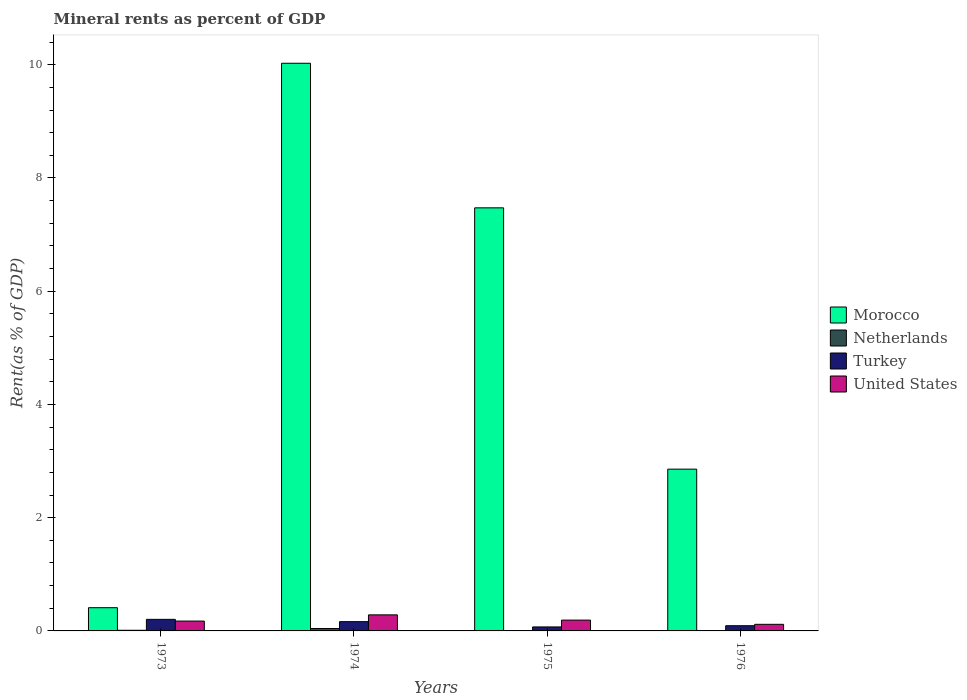How many different coloured bars are there?
Offer a very short reply. 4. How many groups of bars are there?
Keep it short and to the point. 4. Are the number of bars per tick equal to the number of legend labels?
Provide a succinct answer. Yes. Are the number of bars on each tick of the X-axis equal?
Your answer should be very brief. Yes. How many bars are there on the 4th tick from the right?
Your answer should be very brief. 4. What is the label of the 3rd group of bars from the left?
Keep it short and to the point. 1975. In how many cases, is the number of bars for a given year not equal to the number of legend labels?
Provide a succinct answer. 0. What is the mineral rent in Morocco in 1974?
Offer a very short reply. 10.03. Across all years, what is the maximum mineral rent in United States?
Provide a short and direct response. 0.28. Across all years, what is the minimum mineral rent in Netherlands?
Ensure brevity in your answer.  0. In which year was the mineral rent in Netherlands maximum?
Your answer should be very brief. 1974. In which year was the mineral rent in Turkey minimum?
Offer a terse response. 1975. What is the total mineral rent in Morocco in the graph?
Provide a succinct answer. 20.77. What is the difference between the mineral rent in United States in 1973 and that in 1976?
Your answer should be compact. 0.06. What is the difference between the mineral rent in Turkey in 1976 and the mineral rent in Morocco in 1974?
Your response must be concise. -9.93. What is the average mineral rent in Netherlands per year?
Your answer should be compact. 0.01. In the year 1976, what is the difference between the mineral rent in United States and mineral rent in Netherlands?
Keep it short and to the point. 0.12. What is the ratio of the mineral rent in Netherlands in 1974 to that in 1975?
Keep it short and to the point. 22.01. Is the difference between the mineral rent in United States in 1973 and 1974 greater than the difference between the mineral rent in Netherlands in 1973 and 1974?
Your answer should be very brief. No. What is the difference between the highest and the second highest mineral rent in Turkey?
Provide a succinct answer. 0.04. What is the difference between the highest and the lowest mineral rent in Netherlands?
Make the answer very short. 0.04. Is it the case that in every year, the sum of the mineral rent in United States and mineral rent in Turkey is greater than the sum of mineral rent in Morocco and mineral rent in Netherlands?
Provide a succinct answer. Yes. What does the 1st bar from the left in 1974 represents?
Offer a very short reply. Morocco. What does the 4th bar from the right in 1974 represents?
Your answer should be compact. Morocco. Is it the case that in every year, the sum of the mineral rent in Morocco and mineral rent in Netherlands is greater than the mineral rent in Turkey?
Your response must be concise. Yes. Are all the bars in the graph horizontal?
Your response must be concise. No. What is the difference between two consecutive major ticks on the Y-axis?
Give a very brief answer. 2. Does the graph contain grids?
Provide a succinct answer. No. What is the title of the graph?
Your response must be concise. Mineral rents as percent of GDP. Does "Greece" appear as one of the legend labels in the graph?
Provide a short and direct response. No. What is the label or title of the Y-axis?
Provide a short and direct response. Rent(as % of GDP). What is the Rent(as % of GDP) in Morocco in 1973?
Keep it short and to the point. 0.41. What is the Rent(as % of GDP) of Netherlands in 1973?
Ensure brevity in your answer.  0.01. What is the Rent(as % of GDP) in Turkey in 1973?
Provide a short and direct response. 0.2. What is the Rent(as % of GDP) in United States in 1973?
Ensure brevity in your answer.  0.17. What is the Rent(as % of GDP) of Morocco in 1974?
Ensure brevity in your answer.  10.03. What is the Rent(as % of GDP) in Netherlands in 1974?
Your response must be concise. 0.04. What is the Rent(as % of GDP) of Turkey in 1974?
Provide a short and direct response. 0.16. What is the Rent(as % of GDP) of United States in 1974?
Ensure brevity in your answer.  0.28. What is the Rent(as % of GDP) in Morocco in 1975?
Provide a short and direct response. 7.47. What is the Rent(as % of GDP) in Netherlands in 1975?
Provide a short and direct response. 0. What is the Rent(as % of GDP) of Turkey in 1975?
Keep it short and to the point. 0.07. What is the Rent(as % of GDP) in United States in 1975?
Provide a succinct answer. 0.19. What is the Rent(as % of GDP) of Morocco in 1976?
Keep it short and to the point. 2.86. What is the Rent(as % of GDP) of Netherlands in 1976?
Your response must be concise. 0. What is the Rent(as % of GDP) of Turkey in 1976?
Your response must be concise. 0.09. What is the Rent(as % of GDP) in United States in 1976?
Ensure brevity in your answer.  0.12. Across all years, what is the maximum Rent(as % of GDP) of Morocco?
Offer a terse response. 10.03. Across all years, what is the maximum Rent(as % of GDP) of Netherlands?
Provide a short and direct response. 0.04. Across all years, what is the maximum Rent(as % of GDP) in Turkey?
Offer a very short reply. 0.2. Across all years, what is the maximum Rent(as % of GDP) in United States?
Offer a very short reply. 0.28. Across all years, what is the minimum Rent(as % of GDP) in Morocco?
Your answer should be very brief. 0.41. Across all years, what is the minimum Rent(as % of GDP) of Netherlands?
Provide a succinct answer. 0. Across all years, what is the minimum Rent(as % of GDP) in Turkey?
Offer a terse response. 0.07. Across all years, what is the minimum Rent(as % of GDP) in United States?
Offer a very short reply. 0.12. What is the total Rent(as % of GDP) in Morocco in the graph?
Offer a very short reply. 20.77. What is the total Rent(as % of GDP) in Netherlands in the graph?
Offer a very short reply. 0.06. What is the total Rent(as % of GDP) in Turkey in the graph?
Your answer should be very brief. 0.53. What is the total Rent(as % of GDP) in United States in the graph?
Offer a very short reply. 0.77. What is the difference between the Rent(as % of GDP) in Morocco in 1973 and that in 1974?
Provide a succinct answer. -9.62. What is the difference between the Rent(as % of GDP) of Netherlands in 1973 and that in 1974?
Keep it short and to the point. -0.03. What is the difference between the Rent(as % of GDP) in Turkey in 1973 and that in 1974?
Offer a very short reply. 0.04. What is the difference between the Rent(as % of GDP) in United States in 1973 and that in 1974?
Your answer should be compact. -0.11. What is the difference between the Rent(as % of GDP) in Morocco in 1973 and that in 1975?
Your response must be concise. -7.06. What is the difference between the Rent(as % of GDP) of Netherlands in 1973 and that in 1975?
Offer a very short reply. 0.01. What is the difference between the Rent(as % of GDP) in Turkey in 1973 and that in 1975?
Ensure brevity in your answer.  0.13. What is the difference between the Rent(as % of GDP) in United States in 1973 and that in 1975?
Provide a short and direct response. -0.02. What is the difference between the Rent(as % of GDP) in Morocco in 1973 and that in 1976?
Provide a short and direct response. -2.45. What is the difference between the Rent(as % of GDP) in Netherlands in 1973 and that in 1976?
Provide a short and direct response. 0.01. What is the difference between the Rent(as % of GDP) in Turkey in 1973 and that in 1976?
Offer a very short reply. 0.11. What is the difference between the Rent(as % of GDP) of United States in 1973 and that in 1976?
Provide a succinct answer. 0.06. What is the difference between the Rent(as % of GDP) of Morocco in 1974 and that in 1975?
Ensure brevity in your answer.  2.55. What is the difference between the Rent(as % of GDP) of Netherlands in 1974 and that in 1975?
Your answer should be very brief. 0.04. What is the difference between the Rent(as % of GDP) of Turkey in 1974 and that in 1975?
Offer a terse response. 0.09. What is the difference between the Rent(as % of GDP) in United States in 1974 and that in 1975?
Ensure brevity in your answer.  0.09. What is the difference between the Rent(as % of GDP) of Morocco in 1974 and that in 1976?
Provide a succinct answer. 7.17. What is the difference between the Rent(as % of GDP) of Netherlands in 1974 and that in 1976?
Ensure brevity in your answer.  0.04. What is the difference between the Rent(as % of GDP) of Turkey in 1974 and that in 1976?
Offer a very short reply. 0.07. What is the difference between the Rent(as % of GDP) of United States in 1974 and that in 1976?
Offer a terse response. 0.17. What is the difference between the Rent(as % of GDP) of Morocco in 1975 and that in 1976?
Your answer should be compact. 4.62. What is the difference between the Rent(as % of GDP) in Netherlands in 1975 and that in 1976?
Provide a short and direct response. 0. What is the difference between the Rent(as % of GDP) of Turkey in 1975 and that in 1976?
Ensure brevity in your answer.  -0.02. What is the difference between the Rent(as % of GDP) in United States in 1975 and that in 1976?
Ensure brevity in your answer.  0.07. What is the difference between the Rent(as % of GDP) in Morocco in 1973 and the Rent(as % of GDP) in Netherlands in 1974?
Your answer should be compact. 0.37. What is the difference between the Rent(as % of GDP) of Morocco in 1973 and the Rent(as % of GDP) of Turkey in 1974?
Keep it short and to the point. 0.25. What is the difference between the Rent(as % of GDP) of Morocco in 1973 and the Rent(as % of GDP) of United States in 1974?
Ensure brevity in your answer.  0.13. What is the difference between the Rent(as % of GDP) of Netherlands in 1973 and the Rent(as % of GDP) of Turkey in 1974?
Your answer should be very brief. -0.15. What is the difference between the Rent(as % of GDP) of Netherlands in 1973 and the Rent(as % of GDP) of United States in 1974?
Give a very brief answer. -0.27. What is the difference between the Rent(as % of GDP) in Turkey in 1973 and the Rent(as % of GDP) in United States in 1974?
Keep it short and to the point. -0.08. What is the difference between the Rent(as % of GDP) of Morocco in 1973 and the Rent(as % of GDP) of Netherlands in 1975?
Provide a succinct answer. 0.41. What is the difference between the Rent(as % of GDP) of Morocco in 1973 and the Rent(as % of GDP) of Turkey in 1975?
Ensure brevity in your answer.  0.34. What is the difference between the Rent(as % of GDP) in Morocco in 1973 and the Rent(as % of GDP) in United States in 1975?
Your response must be concise. 0.22. What is the difference between the Rent(as % of GDP) in Netherlands in 1973 and the Rent(as % of GDP) in Turkey in 1975?
Your answer should be very brief. -0.06. What is the difference between the Rent(as % of GDP) of Netherlands in 1973 and the Rent(as % of GDP) of United States in 1975?
Provide a succinct answer. -0.18. What is the difference between the Rent(as % of GDP) in Turkey in 1973 and the Rent(as % of GDP) in United States in 1975?
Give a very brief answer. 0.01. What is the difference between the Rent(as % of GDP) of Morocco in 1973 and the Rent(as % of GDP) of Netherlands in 1976?
Make the answer very short. 0.41. What is the difference between the Rent(as % of GDP) in Morocco in 1973 and the Rent(as % of GDP) in Turkey in 1976?
Offer a terse response. 0.32. What is the difference between the Rent(as % of GDP) in Morocco in 1973 and the Rent(as % of GDP) in United States in 1976?
Ensure brevity in your answer.  0.29. What is the difference between the Rent(as % of GDP) of Netherlands in 1973 and the Rent(as % of GDP) of Turkey in 1976?
Offer a terse response. -0.08. What is the difference between the Rent(as % of GDP) of Netherlands in 1973 and the Rent(as % of GDP) of United States in 1976?
Keep it short and to the point. -0.11. What is the difference between the Rent(as % of GDP) in Turkey in 1973 and the Rent(as % of GDP) in United States in 1976?
Provide a succinct answer. 0.09. What is the difference between the Rent(as % of GDP) of Morocco in 1974 and the Rent(as % of GDP) of Netherlands in 1975?
Your answer should be very brief. 10.02. What is the difference between the Rent(as % of GDP) of Morocco in 1974 and the Rent(as % of GDP) of Turkey in 1975?
Give a very brief answer. 9.96. What is the difference between the Rent(as % of GDP) in Morocco in 1974 and the Rent(as % of GDP) in United States in 1975?
Keep it short and to the point. 9.83. What is the difference between the Rent(as % of GDP) in Netherlands in 1974 and the Rent(as % of GDP) in Turkey in 1975?
Your answer should be very brief. -0.03. What is the difference between the Rent(as % of GDP) of Netherlands in 1974 and the Rent(as % of GDP) of United States in 1975?
Your answer should be compact. -0.15. What is the difference between the Rent(as % of GDP) in Turkey in 1974 and the Rent(as % of GDP) in United States in 1975?
Make the answer very short. -0.03. What is the difference between the Rent(as % of GDP) in Morocco in 1974 and the Rent(as % of GDP) in Netherlands in 1976?
Your answer should be compact. 10.03. What is the difference between the Rent(as % of GDP) in Morocco in 1974 and the Rent(as % of GDP) in Turkey in 1976?
Ensure brevity in your answer.  9.93. What is the difference between the Rent(as % of GDP) of Morocco in 1974 and the Rent(as % of GDP) of United States in 1976?
Ensure brevity in your answer.  9.91. What is the difference between the Rent(as % of GDP) of Netherlands in 1974 and the Rent(as % of GDP) of Turkey in 1976?
Make the answer very short. -0.05. What is the difference between the Rent(as % of GDP) in Netherlands in 1974 and the Rent(as % of GDP) in United States in 1976?
Offer a very short reply. -0.07. What is the difference between the Rent(as % of GDP) of Turkey in 1974 and the Rent(as % of GDP) of United States in 1976?
Offer a terse response. 0.05. What is the difference between the Rent(as % of GDP) in Morocco in 1975 and the Rent(as % of GDP) in Netherlands in 1976?
Your answer should be very brief. 7.47. What is the difference between the Rent(as % of GDP) of Morocco in 1975 and the Rent(as % of GDP) of Turkey in 1976?
Offer a very short reply. 7.38. What is the difference between the Rent(as % of GDP) in Morocco in 1975 and the Rent(as % of GDP) in United States in 1976?
Your answer should be compact. 7.36. What is the difference between the Rent(as % of GDP) of Netherlands in 1975 and the Rent(as % of GDP) of Turkey in 1976?
Your response must be concise. -0.09. What is the difference between the Rent(as % of GDP) in Netherlands in 1975 and the Rent(as % of GDP) in United States in 1976?
Give a very brief answer. -0.11. What is the difference between the Rent(as % of GDP) of Turkey in 1975 and the Rent(as % of GDP) of United States in 1976?
Your answer should be very brief. -0.05. What is the average Rent(as % of GDP) in Morocco per year?
Provide a short and direct response. 5.19. What is the average Rent(as % of GDP) in Netherlands per year?
Ensure brevity in your answer.  0.01. What is the average Rent(as % of GDP) of Turkey per year?
Your answer should be very brief. 0.13. What is the average Rent(as % of GDP) of United States per year?
Ensure brevity in your answer.  0.19. In the year 1973, what is the difference between the Rent(as % of GDP) of Morocco and Rent(as % of GDP) of Netherlands?
Your answer should be compact. 0.4. In the year 1973, what is the difference between the Rent(as % of GDP) of Morocco and Rent(as % of GDP) of Turkey?
Give a very brief answer. 0.21. In the year 1973, what is the difference between the Rent(as % of GDP) in Morocco and Rent(as % of GDP) in United States?
Give a very brief answer. 0.24. In the year 1973, what is the difference between the Rent(as % of GDP) of Netherlands and Rent(as % of GDP) of Turkey?
Ensure brevity in your answer.  -0.19. In the year 1973, what is the difference between the Rent(as % of GDP) in Netherlands and Rent(as % of GDP) in United States?
Give a very brief answer. -0.16. In the year 1973, what is the difference between the Rent(as % of GDP) of Turkey and Rent(as % of GDP) of United States?
Offer a very short reply. 0.03. In the year 1974, what is the difference between the Rent(as % of GDP) of Morocco and Rent(as % of GDP) of Netherlands?
Your answer should be compact. 9.98. In the year 1974, what is the difference between the Rent(as % of GDP) of Morocco and Rent(as % of GDP) of Turkey?
Keep it short and to the point. 9.86. In the year 1974, what is the difference between the Rent(as % of GDP) in Morocco and Rent(as % of GDP) in United States?
Keep it short and to the point. 9.74. In the year 1974, what is the difference between the Rent(as % of GDP) in Netherlands and Rent(as % of GDP) in Turkey?
Provide a short and direct response. -0.12. In the year 1974, what is the difference between the Rent(as % of GDP) of Netherlands and Rent(as % of GDP) of United States?
Give a very brief answer. -0.24. In the year 1974, what is the difference between the Rent(as % of GDP) of Turkey and Rent(as % of GDP) of United States?
Make the answer very short. -0.12. In the year 1975, what is the difference between the Rent(as % of GDP) of Morocco and Rent(as % of GDP) of Netherlands?
Your answer should be very brief. 7.47. In the year 1975, what is the difference between the Rent(as % of GDP) of Morocco and Rent(as % of GDP) of Turkey?
Ensure brevity in your answer.  7.4. In the year 1975, what is the difference between the Rent(as % of GDP) of Morocco and Rent(as % of GDP) of United States?
Your response must be concise. 7.28. In the year 1975, what is the difference between the Rent(as % of GDP) in Netherlands and Rent(as % of GDP) in Turkey?
Keep it short and to the point. -0.07. In the year 1975, what is the difference between the Rent(as % of GDP) of Netherlands and Rent(as % of GDP) of United States?
Your answer should be very brief. -0.19. In the year 1975, what is the difference between the Rent(as % of GDP) in Turkey and Rent(as % of GDP) in United States?
Your response must be concise. -0.12. In the year 1976, what is the difference between the Rent(as % of GDP) in Morocco and Rent(as % of GDP) in Netherlands?
Your answer should be very brief. 2.86. In the year 1976, what is the difference between the Rent(as % of GDP) of Morocco and Rent(as % of GDP) of Turkey?
Offer a terse response. 2.77. In the year 1976, what is the difference between the Rent(as % of GDP) in Morocco and Rent(as % of GDP) in United States?
Provide a succinct answer. 2.74. In the year 1976, what is the difference between the Rent(as % of GDP) of Netherlands and Rent(as % of GDP) of Turkey?
Provide a succinct answer. -0.09. In the year 1976, what is the difference between the Rent(as % of GDP) in Netherlands and Rent(as % of GDP) in United States?
Offer a very short reply. -0.12. In the year 1976, what is the difference between the Rent(as % of GDP) of Turkey and Rent(as % of GDP) of United States?
Make the answer very short. -0.02. What is the ratio of the Rent(as % of GDP) of Morocco in 1973 to that in 1974?
Offer a terse response. 0.04. What is the ratio of the Rent(as % of GDP) in Netherlands in 1973 to that in 1974?
Ensure brevity in your answer.  0.27. What is the ratio of the Rent(as % of GDP) in Turkey in 1973 to that in 1974?
Offer a very short reply. 1.25. What is the ratio of the Rent(as % of GDP) of United States in 1973 to that in 1974?
Your response must be concise. 0.61. What is the ratio of the Rent(as % of GDP) of Morocco in 1973 to that in 1975?
Keep it short and to the point. 0.05. What is the ratio of the Rent(as % of GDP) in Netherlands in 1973 to that in 1975?
Offer a very short reply. 5.97. What is the ratio of the Rent(as % of GDP) in Turkey in 1973 to that in 1975?
Your response must be concise. 2.89. What is the ratio of the Rent(as % of GDP) in United States in 1973 to that in 1975?
Your response must be concise. 0.91. What is the ratio of the Rent(as % of GDP) of Morocco in 1973 to that in 1976?
Your answer should be compact. 0.14. What is the ratio of the Rent(as % of GDP) in Netherlands in 1973 to that in 1976?
Your answer should be compact. 21.57. What is the ratio of the Rent(as % of GDP) of Turkey in 1973 to that in 1976?
Keep it short and to the point. 2.22. What is the ratio of the Rent(as % of GDP) in United States in 1973 to that in 1976?
Your answer should be very brief. 1.49. What is the ratio of the Rent(as % of GDP) of Morocco in 1974 to that in 1975?
Provide a short and direct response. 1.34. What is the ratio of the Rent(as % of GDP) of Netherlands in 1974 to that in 1975?
Offer a terse response. 22.01. What is the ratio of the Rent(as % of GDP) of Turkey in 1974 to that in 1975?
Your response must be concise. 2.32. What is the ratio of the Rent(as % of GDP) in United States in 1974 to that in 1975?
Your answer should be very brief. 1.48. What is the ratio of the Rent(as % of GDP) in Morocco in 1974 to that in 1976?
Give a very brief answer. 3.51. What is the ratio of the Rent(as % of GDP) of Netherlands in 1974 to that in 1976?
Your answer should be compact. 79.49. What is the ratio of the Rent(as % of GDP) of Turkey in 1974 to that in 1976?
Offer a very short reply. 1.78. What is the ratio of the Rent(as % of GDP) of United States in 1974 to that in 1976?
Provide a succinct answer. 2.43. What is the ratio of the Rent(as % of GDP) of Morocco in 1975 to that in 1976?
Keep it short and to the point. 2.62. What is the ratio of the Rent(as % of GDP) in Netherlands in 1975 to that in 1976?
Give a very brief answer. 3.61. What is the ratio of the Rent(as % of GDP) in Turkey in 1975 to that in 1976?
Give a very brief answer. 0.77. What is the ratio of the Rent(as % of GDP) of United States in 1975 to that in 1976?
Your response must be concise. 1.64. What is the difference between the highest and the second highest Rent(as % of GDP) in Morocco?
Ensure brevity in your answer.  2.55. What is the difference between the highest and the second highest Rent(as % of GDP) in Netherlands?
Provide a short and direct response. 0.03. What is the difference between the highest and the second highest Rent(as % of GDP) of Turkey?
Offer a very short reply. 0.04. What is the difference between the highest and the second highest Rent(as % of GDP) of United States?
Offer a terse response. 0.09. What is the difference between the highest and the lowest Rent(as % of GDP) of Morocco?
Keep it short and to the point. 9.62. What is the difference between the highest and the lowest Rent(as % of GDP) of Netherlands?
Your answer should be compact. 0.04. What is the difference between the highest and the lowest Rent(as % of GDP) of Turkey?
Your answer should be very brief. 0.13. What is the difference between the highest and the lowest Rent(as % of GDP) of United States?
Offer a terse response. 0.17. 